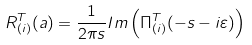Convert formula to latex. <formula><loc_0><loc_0><loc_500><loc_500>R ^ { T } _ { ( i ) } ( a ) = \frac { 1 } { 2 \pi s } I m \left ( \Pi ^ { T } _ { ( i ) } ( - s - i \varepsilon ) \right )</formula> 